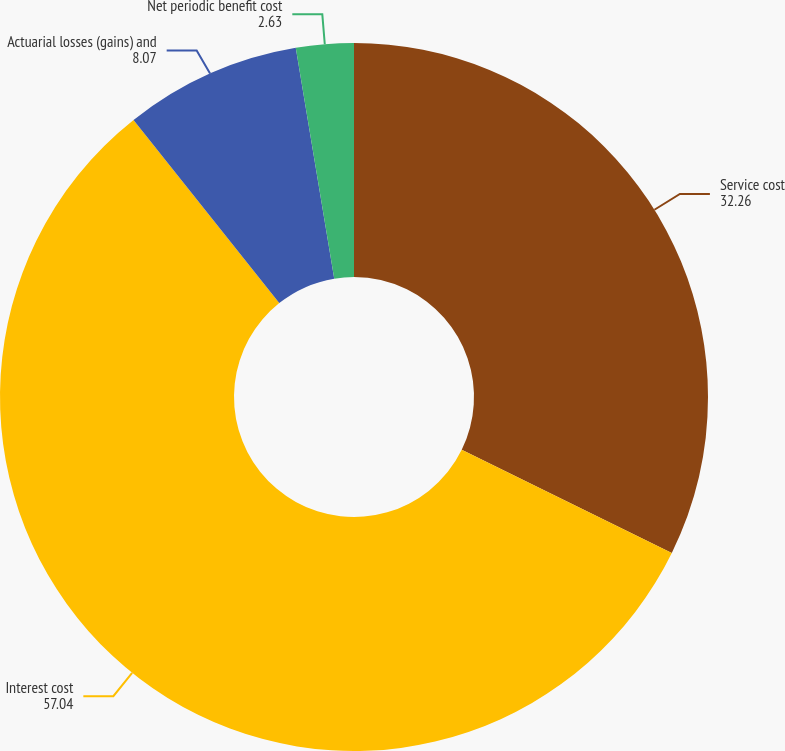<chart> <loc_0><loc_0><loc_500><loc_500><pie_chart><fcel>Service cost<fcel>Interest cost<fcel>Actuarial losses (gains) and<fcel>Net periodic benefit cost<nl><fcel>32.26%<fcel>57.04%<fcel>8.07%<fcel>2.63%<nl></chart> 